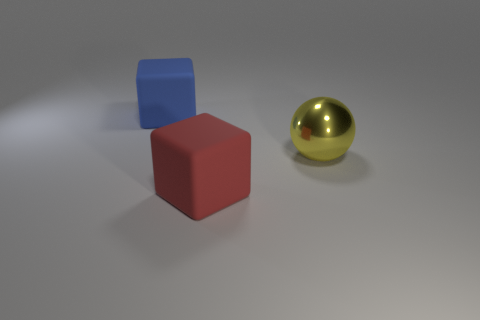Add 2 small brown shiny blocks. How many objects exist? 5 Add 1 small yellow shiny cylinders. How many small yellow shiny cylinders exist? 1 Subtract 1 yellow balls. How many objects are left? 2 Subtract all balls. How many objects are left? 2 Subtract all green blocks. Subtract all blue spheres. How many blocks are left? 2 Subtract all large blue matte balls. Subtract all yellow objects. How many objects are left? 2 Add 1 blue objects. How many blue objects are left? 2 